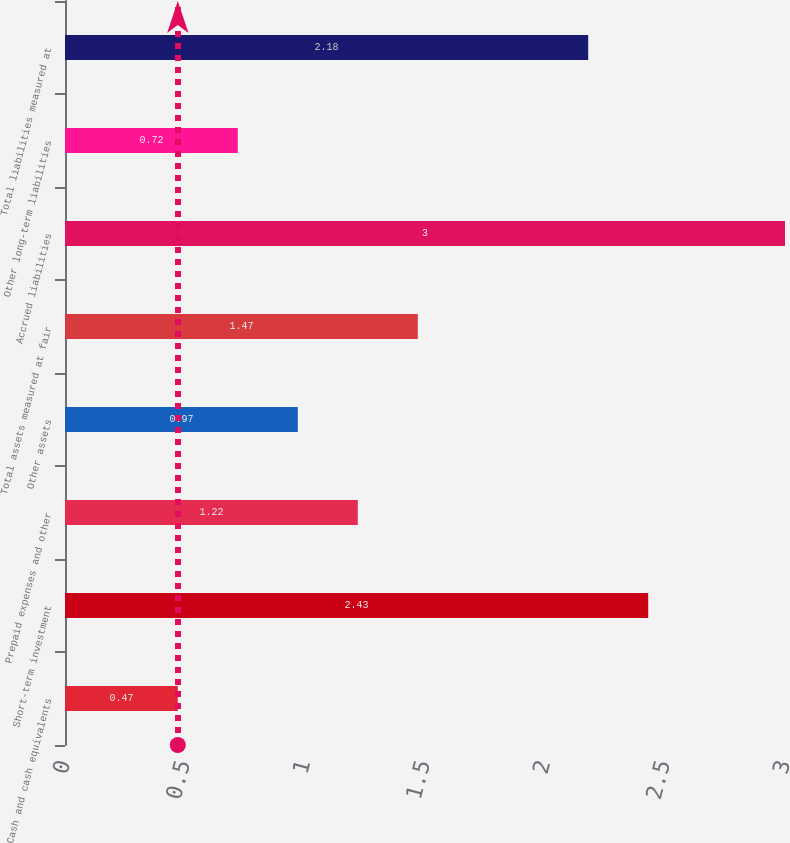<chart> <loc_0><loc_0><loc_500><loc_500><bar_chart><fcel>Cash and cash equivalents<fcel>Short-term investment<fcel>Prepaid expenses and other<fcel>Other assets<fcel>Total assets measured at fair<fcel>Accrued liabilities<fcel>Other long-term liabilities<fcel>Total liabilities measured at<nl><fcel>0.47<fcel>2.43<fcel>1.22<fcel>0.97<fcel>1.47<fcel>3<fcel>0.72<fcel>2.18<nl></chart> 